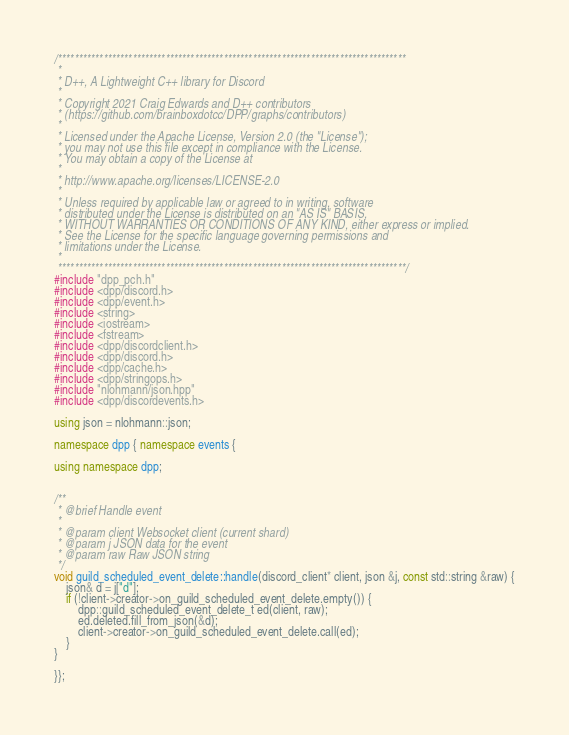Convert code to text. <code><loc_0><loc_0><loc_500><loc_500><_C++_>/************************************************************************************
 *
 * D++, A Lightweight C++ library for Discord
 *
 * Copyright 2021 Craig Edwards and D++ contributors 
 * (https://github.com/brainboxdotcc/DPP/graphs/contributors)
 *
 * Licensed under the Apache License, Version 2.0 (the "License");
 * you may not use this file except in compliance with the License.
 * You may obtain a copy of the License at
 *
 * http://www.apache.org/licenses/LICENSE-2.0
 *
 * Unless required by applicable law or agreed to in writing, software
 * distributed under the License is distributed on an "AS IS" BASIS,
 * WITHOUT WARRANTIES OR CONDITIONS OF ANY KIND, either express or implied.
 * See the License for the specific language governing permissions and
 * limitations under the License.
 *
 ************************************************************************************/
#include "dpp_pch.h"
#include <dpp/discord.h>
#include <dpp/event.h>
#include <string>
#include <iostream>
#include <fstream>
#include <dpp/discordclient.h>
#include <dpp/discord.h>
#include <dpp/cache.h>
#include <dpp/stringops.h>
#include "nlohmann/json.hpp"
#include <dpp/discordevents.h>

using json = nlohmann::json;

namespace dpp { namespace events {

using namespace dpp;


/**
 * @brief Handle event
 * 
 * @param client Websocket client (current shard)
 * @param j JSON data for the event
 * @param raw Raw JSON string
 */
void guild_scheduled_event_delete::handle(discord_client* client, json &j, const std::string &raw) {
	json& d = j["d"];
	if (!client->creator->on_guild_scheduled_event_delete.empty()) {
		dpp::guild_scheduled_event_delete_t ed(client, raw);
		ed.deleted.fill_from_json(&d);
		client->creator->on_guild_scheduled_event_delete.call(ed);
	}
}

}};</code> 